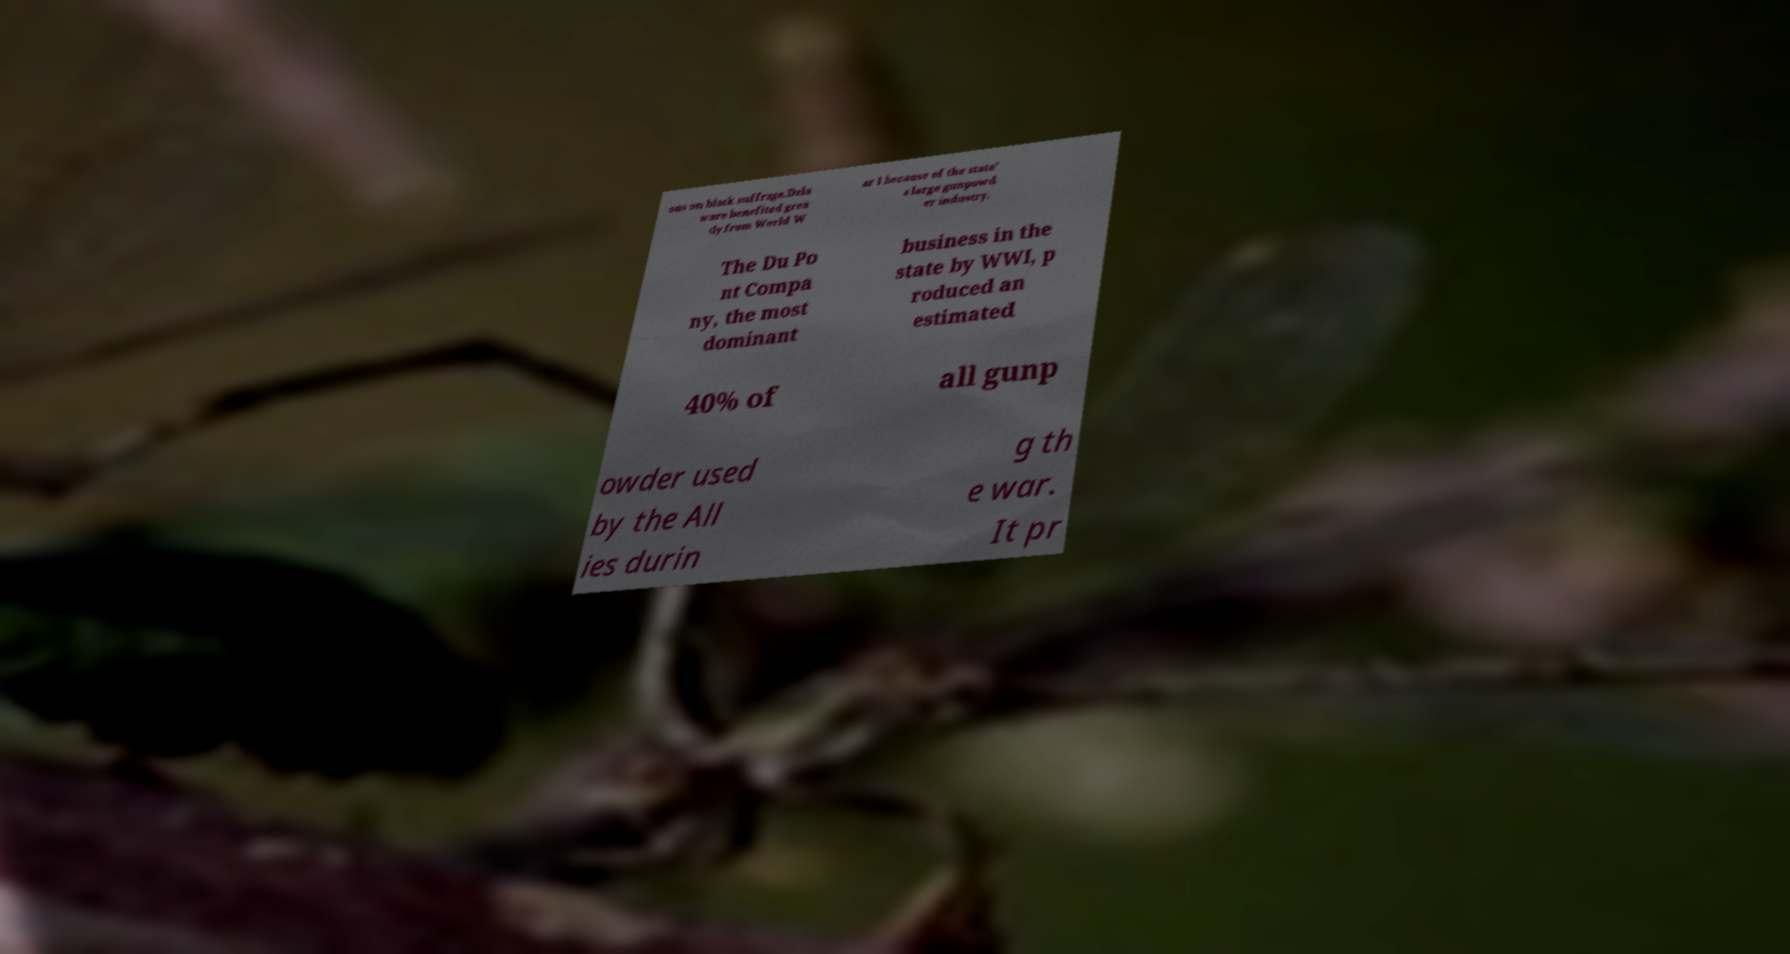Can you accurately transcribe the text from the provided image for me? ons on black suffrage.Dela ware benefited grea tly from World W ar I because of the state' s large gunpowd er industry. The Du Po nt Compa ny, the most dominant business in the state by WWI, p roduced an estimated 40% of all gunp owder used by the All ies durin g th e war. It pr 